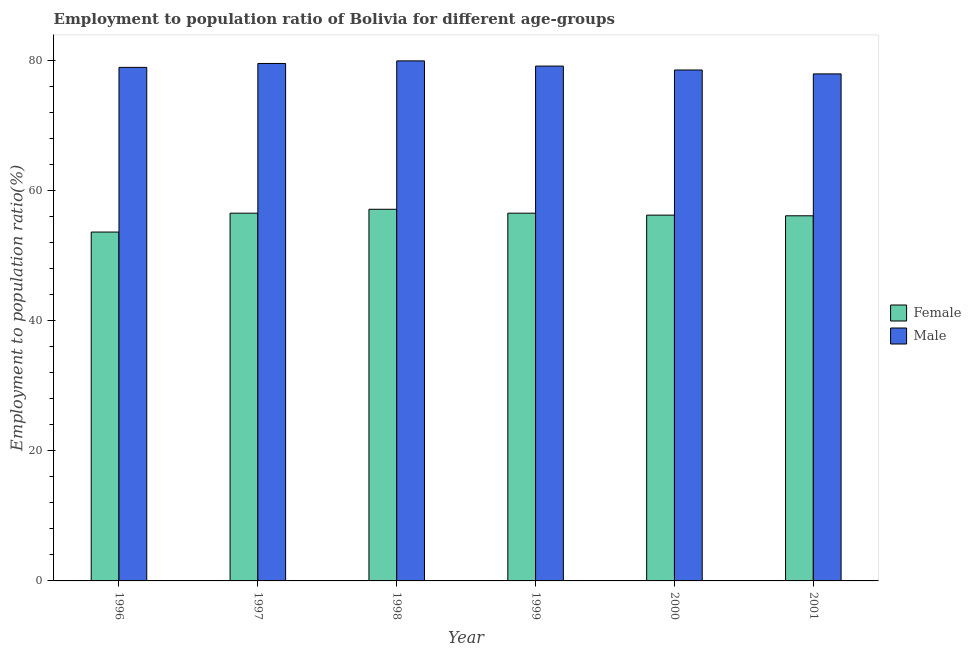How many different coloured bars are there?
Your answer should be very brief. 2. How many groups of bars are there?
Offer a very short reply. 6. Are the number of bars per tick equal to the number of legend labels?
Offer a terse response. Yes. Are the number of bars on each tick of the X-axis equal?
Your answer should be very brief. Yes. In how many cases, is the number of bars for a given year not equal to the number of legend labels?
Offer a terse response. 0. What is the employment to population ratio(male) in 2001?
Offer a terse response. 77.9. Across all years, what is the maximum employment to population ratio(male)?
Your response must be concise. 79.9. Across all years, what is the minimum employment to population ratio(female)?
Offer a terse response. 53.6. What is the total employment to population ratio(female) in the graph?
Your answer should be very brief. 336. What is the difference between the employment to population ratio(male) in 1997 and the employment to population ratio(female) in 2000?
Keep it short and to the point. 1. What is the average employment to population ratio(female) per year?
Keep it short and to the point. 56. In the year 1996, what is the difference between the employment to population ratio(male) and employment to population ratio(female)?
Make the answer very short. 0. What is the ratio of the employment to population ratio(female) in 1996 to that in 1998?
Provide a succinct answer. 0.94. What is the difference between the highest and the second highest employment to population ratio(female)?
Your answer should be very brief. 0.6. What is the difference between the highest and the lowest employment to population ratio(male)?
Provide a short and direct response. 2. What does the 1st bar from the right in 2001 represents?
Ensure brevity in your answer.  Male. How many bars are there?
Offer a terse response. 12. Are all the bars in the graph horizontal?
Your response must be concise. No. Does the graph contain grids?
Your answer should be very brief. No. Where does the legend appear in the graph?
Make the answer very short. Center right. How many legend labels are there?
Keep it short and to the point. 2. How are the legend labels stacked?
Provide a succinct answer. Vertical. What is the title of the graph?
Provide a short and direct response. Employment to population ratio of Bolivia for different age-groups. What is the Employment to population ratio(%) of Female in 1996?
Your answer should be very brief. 53.6. What is the Employment to population ratio(%) of Male in 1996?
Offer a very short reply. 78.9. What is the Employment to population ratio(%) in Female in 1997?
Give a very brief answer. 56.5. What is the Employment to population ratio(%) of Male in 1997?
Your answer should be very brief. 79.5. What is the Employment to population ratio(%) of Female in 1998?
Offer a very short reply. 57.1. What is the Employment to population ratio(%) in Male in 1998?
Provide a short and direct response. 79.9. What is the Employment to population ratio(%) in Female in 1999?
Ensure brevity in your answer.  56.5. What is the Employment to population ratio(%) in Male in 1999?
Your response must be concise. 79.1. What is the Employment to population ratio(%) in Female in 2000?
Provide a short and direct response. 56.2. What is the Employment to population ratio(%) of Male in 2000?
Offer a very short reply. 78.5. What is the Employment to population ratio(%) of Female in 2001?
Make the answer very short. 56.1. What is the Employment to population ratio(%) in Male in 2001?
Ensure brevity in your answer.  77.9. Across all years, what is the maximum Employment to population ratio(%) of Female?
Give a very brief answer. 57.1. Across all years, what is the maximum Employment to population ratio(%) in Male?
Keep it short and to the point. 79.9. Across all years, what is the minimum Employment to population ratio(%) of Female?
Make the answer very short. 53.6. Across all years, what is the minimum Employment to population ratio(%) in Male?
Your answer should be very brief. 77.9. What is the total Employment to population ratio(%) in Female in the graph?
Offer a terse response. 336. What is the total Employment to population ratio(%) of Male in the graph?
Offer a very short reply. 473.8. What is the difference between the Employment to population ratio(%) of Female in 1996 and that in 1998?
Make the answer very short. -3.5. What is the difference between the Employment to population ratio(%) in Male in 1996 and that in 1998?
Your answer should be compact. -1. What is the difference between the Employment to population ratio(%) of Female in 1996 and that in 1999?
Offer a very short reply. -2.9. What is the difference between the Employment to population ratio(%) in Male in 1996 and that in 1999?
Keep it short and to the point. -0.2. What is the difference between the Employment to population ratio(%) in Female in 1996 and that in 2001?
Ensure brevity in your answer.  -2.5. What is the difference between the Employment to population ratio(%) in Male in 1996 and that in 2001?
Provide a short and direct response. 1. What is the difference between the Employment to population ratio(%) of Male in 1997 and that in 1999?
Offer a very short reply. 0.4. What is the difference between the Employment to population ratio(%) in Male in 1997 and that in 2000?
Make the answer very short. 1. What is the difference between the Employment to population ratio(%) of Female in 1997 and that in 2001?
Offer a terse response. 0.4. What is the difference between the Employment to population ratio(%) of Male in 1997 and that in 2001?
Provide a short and direct response. 1.6. What is the difference between the Employment to population ratio(%) in Female in 1998 and that in 1999?
Keep it short and to the point. 0.6. What is the difference between the Employment to population ratio(%) of Female in 1998 and that in 2000?
Make the answer very short. 0.9. What is the difference between the Employment to population ratio(%) in Male in 1998 and that in 2001?
Make the answer very short. 2. What is the difference between the Employment to population ratio(%) of Female in 1999 and that in 2000?
Keep it short and to the point. 0.3. What is the difference between the Employment to population ratio(%) of Male in 1999 and that in 2001?
Your answer should be very brief. 1.2. What is the difference between the Employment to population ratio(%) of Female in 1996 and the Employment to population ratio(%) of Male in 1997?
Make the answer very short. -25.9. What is the difference between the Employment to population ratio(%) in Female in 1996 and the Employment to population ratio(%) in Male in 1998?
Your answer should be compact. -26.3. What is the difference between the Employment to population ratio(%) of Female in 1996 and the Employment to population ratio(%) of Male in 1999?
Make the answer very short. -25.5. What is the difference between the Employment to population ratio(%) of Female in 1996 and the Employment to population ratio(%) of Male in 2000?
Your response must be concise. -24.9. What is the difference between the Employment to population ratio(%) of Female in 1996 and the Employment to population ratio(%) of Male in 2001?
Offer a very short reply. -24.3. What is the difference between the Employment to population ratio(%) in Female in 1997 and the Employment to population ratio(%) in Male in 1998?
Offer a terse response. -23.4. What is the difference between the Employment to population ratio(%) in Female in 1997 and the Employment to population ratio(%) in Male in 1999?
Your response must be concise. -22.6. What is the difference between the Employment to population ratio(%) in Female in 1997 and the Employment to population ratio(%) in Male in 2000?
Provide a succinct answer. -22. What is the difference between the Employment to population ratio(%) in Female in 1997 and the Employment to population ratio(%) in Male in 2001?
Offer a terse response. -21.4. What is the difference between the Employment to population ratio(%) of Female in 1998 and the Employment to population ratio(%) of Male in 1999?
Offer a very short reply. -22. What is the difference between the Employment to population ratio(%) in Female in 1998 and the Employment to population ratio(%) in Male in 2000?
Keep it short and to the point. -21.4. What is the difference between the Employment to population ratio(%) in Female in 1998 and the Employment to population ratio(%) in Male in 2001?
Ensure brevity in your answer.  -20.8. What is the difference between the Employment to population ratio(%) in Female in 1999 and the Employment to population ratio(%) in Male in 2000?
Make the answer very short. -22. What is the difference between the Employment to population ratio(%) of Female in 1999 and the Employment to population ratio(%) of Male in 2001?
Offer a very short reply. -21.4. What is the difference between the Employment to population ratio(%) in Female in 2000 and the Employment to population ratio(%) in Male in 2001?
Ensure brevity in your answer.  -21.7. What is the average Employment to population ratio(%) in Male per year?
Your answer should be compact. 78.97. In the year 1996, what is the difference between the Employment to population ratio(%) in Female and Employment to population ratio(%) in Male?
Provide a short and direct response. -25.3. In the year 1998, what is the difference between the Employment to population ratio(%) in Female and Employment to population ratio(%) in Male?
Make the answer very short. -22.8. In the year 1999, what is the difference between the Employment to population ratio(%) in Female and Employment to population ratio(%) in Male?
Offer a very short reply. -22.6. In the year 2000, what is the difference between the Employment to population ratio(%) of Female and Employment to population ratio(%) of Male?
Provide a succinct answer. -22.3. In the year 2001, what is the difference between the Employment to population ratio(%) in Female and Employment to population ratio(%) in Male?
Give a very brief answer. -21.8. What is the ratio of the Employment to population ratio(%) of Female in 1996 to that in 1997?
Your answer should be very brief. 0.95. What is the ratio of the Employment to population ratio(%) in Female in 1996 to that in 1998?
Offer a terse response. 0.94. What is the ratio of the Employment to population ratio(%) of Male in 1996 to that in 1998?
Offer a terse response. 0.99. What is the ratio of the Employment to population ratio(%) in Female in 1996 to that in 1999?
Your response must be concise. 0.95. What is the ratio of the Employment to population ratio(%) of Female in 1996 to that in 2000?
Your answer should be compact. 0.95. What is the ratio of the Employment to population ratio(%) of Female in 1996 to that in 2001?
Provide a succinct answer. 0.96. What is the ratio of the Employment to population ratio(%) of Male in 1996 to that in 2001?
Offer a very short reply. 1.01. What is the ratio of the Employment to population ratio(%) of Male in 1997 to that in 1998?
Your response must be concise. 0.99. What is the ratio of the Employment to population ratio(%) of Male in 1997 to that in 1999?
Your response must be concise. 1.01. What is the ratio of the Employment to population ratio(%) of Female in 1997 to that in 2000?
Keep it short and to the point. 1.01. What is the ratio of the Employment to population ratio(%) in Male in 1997 to that in 2000?
Your response must be concise. 1.01. What is the ratio of the Employment to population ratio(%) in Female in 1997 to that in 2001?
Your response must be concise. 1.01. What is the ratio of the Employment to population ratio(%) in Male in 1997 to that in 2001?
Offer a very short reply. 1.02. What is the ratio of the Employment to population ratio(%) in Female in 1998 to that in 1999?
Give a very brief answer. 1.01. What is the ratio of the Employment to population ratio(%) of Male in 1998 to that in 2000?
Provide a succinct answer. 1.02. What is the ratio of the Employment to population ratio(%) of Female in 1998 to that in 2001?
Offer a very short reply. 1.02. What is the ratio of the Employment to population ratio(%) of Male in 1998 to that in 2001?
Your answer should be very brief. 1.03. What is the ratio of the Employment to population ratio(%) of Female in 1999 to that in 2000?
Your answer should be very brief. 1.01. What is the ratio of the Employment to population ratio(%) in Male in 1999 to that in 2000?
Provide a short and direct response. 1.01. What is the ratio of the Employment to population ratio(%) in Female in 1999 to that in 2001?
Your answer should be very brief. 1.01. What is the ratio of the Employment to population ratio(%) in Male in 1999 to that in 2001?
Your answer should be compact. 1.02. What is the ratio of the Employment to population ratio(%) of Female in 2000 to that in 2001?
Make the answer very short. 1. What is the ratio of the Employment to population ratio(%) in Male in 2000 to that in 2001?
Offer a terse response. 1.01. What is the difference between the highest and the second highest Employment to population ratio(%) in Male?
Your answer should be very brief. 0.4. 